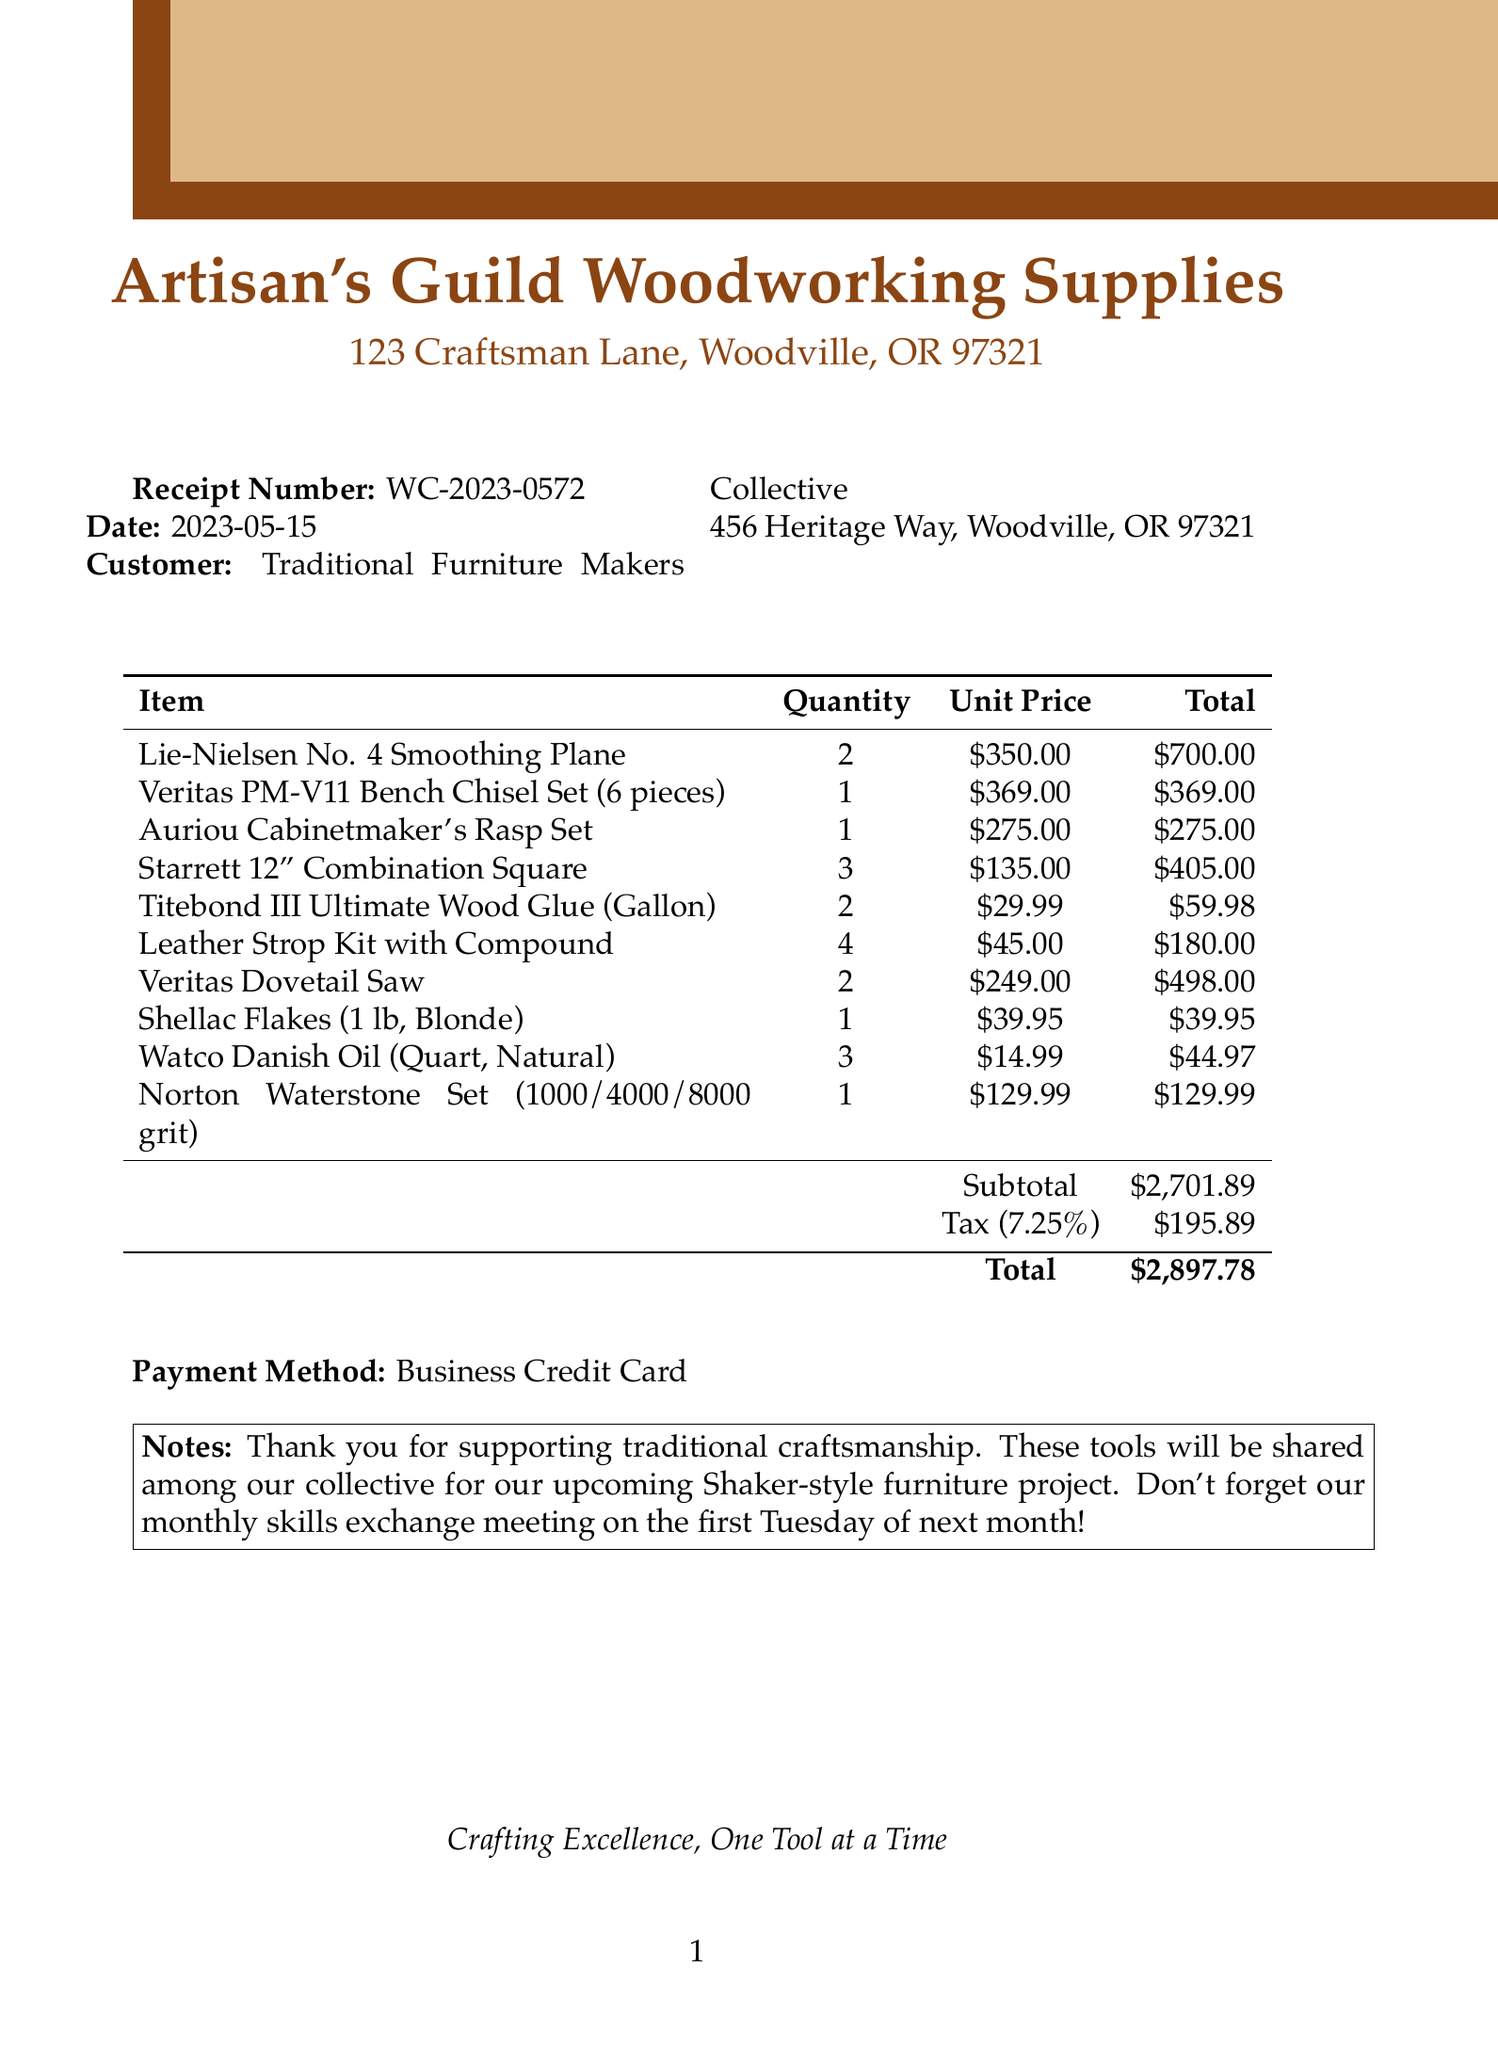What is the receipt number? The receipt number is listed at the top of the document for quick reference.
Answer: WC-2023-0572 What is the date of the receipt? The date is prominently displayed near the receipt number.
Answer: 2023-05-15 Who is the customer? The customer information includes the name of the collective that made the purchase.
Answer: Traditional Furniture Makers Collective What is the subtotal amount? The subtotal is the sum of the costs of the items before tax is applied.
Answer: $2,701.89 How many Titebond III Ultimate Wood Glue (Gallon) were purchased? The quantity is listed next to the item description in the receipt.
Answer: 2 What is the total amount charged? This is the final amount due after tax, which is shown at the bottom of the receipt.
Answer: $2,897.78 What is the payment method used? This is stated in a clear section towards the end of the document.
Answer: Business Credit Card How many different types of chisels were bought? This requires counting the unique chisel items listed, specifically the Veritas PM-V11 Bench Chisel Set.
Answer: 1 What was the purpose of the tools purchased? This is mentioned in the notes section of the receipt, indicating their intended use.
Answer: Shaker-style furniture project 